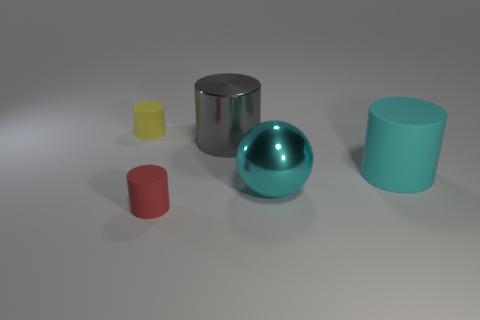There is a gray metal cylinder; is its size the same as the matte cylinder that is on the right side of the small red matte object?
Make the answer very short. Yes. There is a gray object that is the same shape as the small red rubber object; what is it made of?
Offer a terse response. Metal. There is a shiny ball behind the small matte object to the right of the tiny object that is behind the large metallic cylinder; what size is it?
Give a very brief answer. Large. Do the yellow rubber thing and the red thing have the same size?
Your response must be concise. Yes. What is the material of the tiny cylinder that is behind the rubber cylinder that is in front of the big cyan metal ball?
Keep it short and to the point. Rubber. There is a small matte thing that is on the right side of the yellow matte cylinder; is its shape the same as the tiny thing left of the red cylinder?
Offer a terse response. Yes. Are there the same number of cyan matte cylinders left of the red rubber cylinder and yellow rubber objects?
Ensure brevity in your answer.  No. There is a tiny cylinder that is in front of the small yellow matte cylinder; are there any cylinders that are left of it?
Make the answer very short. Yes. Is there anything else that is the same color as the big shiny sphere?
Offer a terse response. Yes. Are the object that is in front of the cyan metal ball and the small yellow object made of the same material?
Your response must be concise. Yes. 